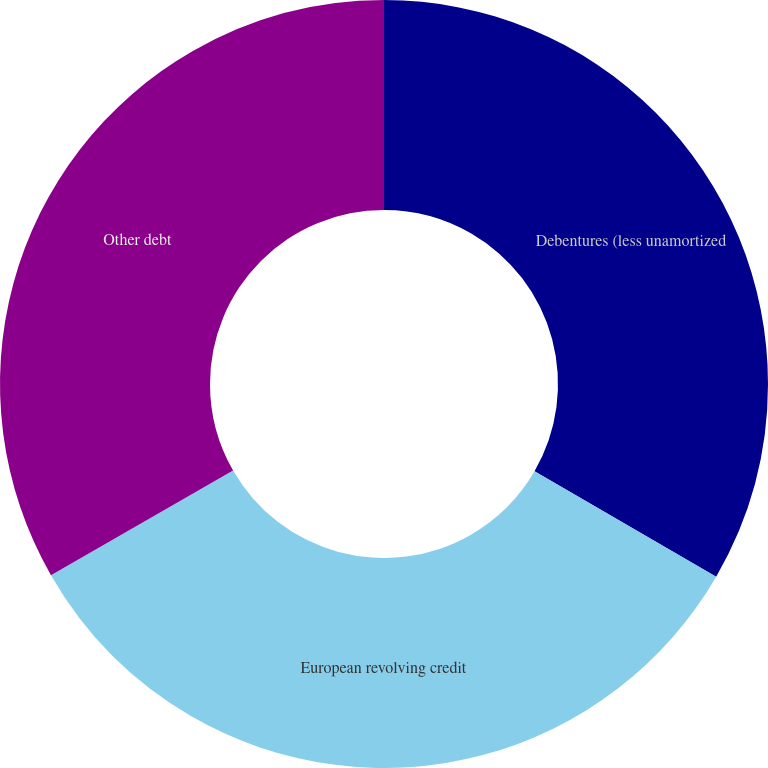Convert chart to OTSL. <chart><loc_0><loc_0><loc_500><loc_500><pie_chart><fcel>Debentures (less unamortized<fcel>European revolving credit<fcel>Other debt<nl><fcel>33.36%<fcel>33.34%<fcel>33.29%<nl></chart> 